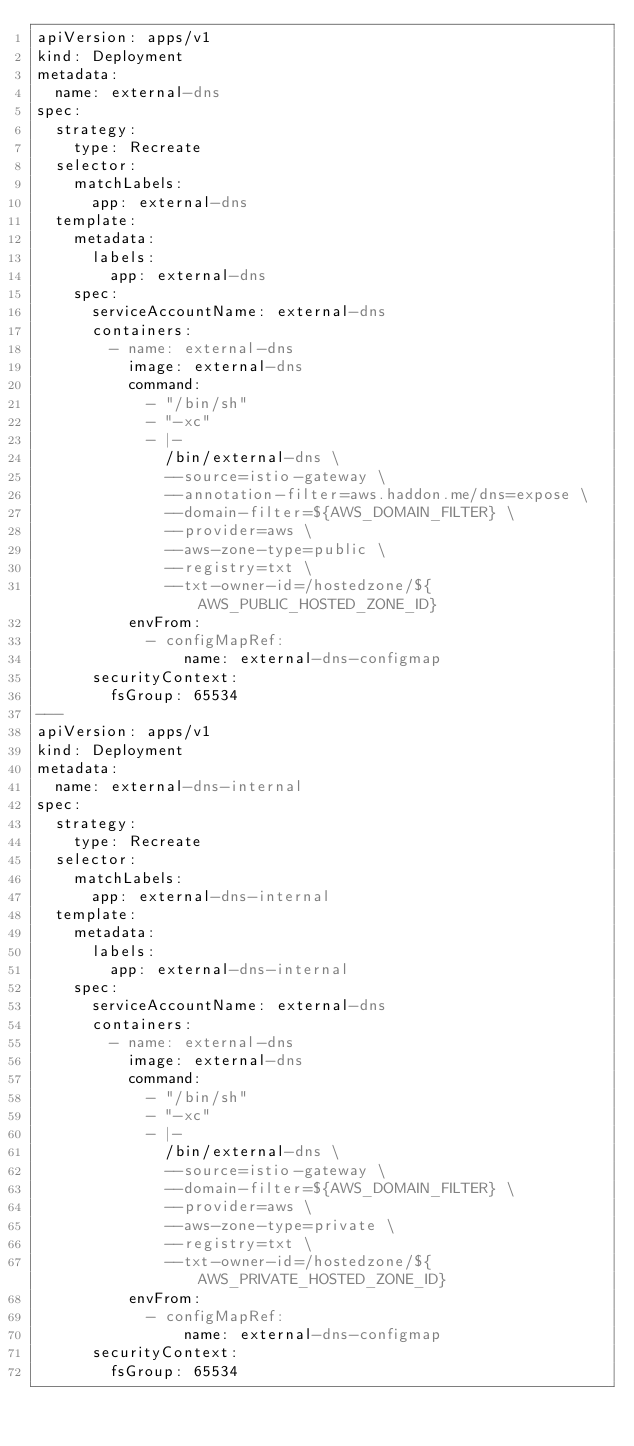<code> <loc_0><loc_0><loc_500><loc_500><_YAML_>apiVersion: apps/v1
kind: Deployment
metadata:
  name: external-dns
spec:
  strategy:
    type: Recreate
  selector:
    matchLabels:
      app: external-dns
  template:
    metadata:
      labels:
        app: external-dns
    spec:
      serviceAccountName: external-dns
      containers:
        - name: external-dns
          image: external-dns
          command:
            - "/bin/sh"
            - "-xc"
            - |-
              /bin/external-dns \
              --source=istio-gateway \
              --annotation-filter=aws.haddon.me/dns=expose \
              --domain-filter=${AWS_DOMAIN_FILTER} \
              --provider=aws \
              --aws-zone-type=public \
              --registry=txt \
              --txt-owner-id=/hostedzone/${AWS_PUBLIC_HOSTED_ZONE_ID}
          envFrom:
            - configMapRef:
                name: external-dns-configmap
      securityContext:
        fsGroup: 65534
---
apiVersion: apps/v1
kind: Deployment
metadata:
  name: external-dns-internal
spec:
  strategy:
    type: Recreate
  selector:
    matchLabels:
      app: external-dns-internal
  template:
    metadata:
      labels:
        app: external-dns-internal
    spec:
      serviceAccountName: external-dns
      containers:
        - name: external-dns
          image: external-dns
          command:
            - "/bin/sh"
            - "-xc"
            - |-
              /bin/external-dns \
              --source=istio-gateway \
              --domain-filter=${AWS_DOMAIN_FILTER} \
              --provider=aws \
              --aws-zone-type=private \
              --registry=txt \
              --txt-owner-id=/hostedzone/${AWS_PRIVATE_HOSTED_ZONE_ID}
          envFrom:
            - configMapRef:
                name: external-dns-configmap
      securityContext:
        fsGroup: 65534</code> 